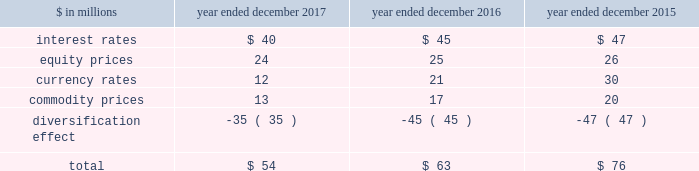The goldman sachs group , inc .
And subsidiaries management 2019s discussion and analysis the risk committee of the board and the risk governance committee ( through delegated authority from the firmwide risk committee ) approve market risk limits and sub-limits at firmwide , business and product levels , consistent with our risk appetite statement .
In addition , market risk management ( through delegated authority from the risk governance committee ) sets market risk limits and sub-limits at certain product and desk levels .
The purpose of the firmwide limits is to assist senior management in controlling our overall risk profile .
Sub-limits are set below the approved level of risk limits .
Sub-limits set the desired maximum amount of exposure that may be managed by any particular business on a day-to-day basis without additional levels of senior management approval , effectively leaving day-to-day decisions to individual desk managers and traders .
Accordingly , sub-limits are a management tool designed to ensure appropriate escalation rather than to establish maximum risk tolerance .
Sub-limits also distribute risk among various businesses in a manner that is consistent with their level of activity and client demand , taking into account the relative performance of each area .
Our market risk limits are monitored daily by market risk management , which is responsible for identifying and escalating , on a timely basis , instances where limits have been exceeded .
When a risk limit has been exceeded ( e.g. , due to positional changes or changes in market conditions , such as increased volatilities or changes in correlations ) , it is escalated to senior managers in market risk management and/or the appropriate risk committee .
Such instances are remediated by an inventory reduction and/or a temporary or permanent increase to the risk limit .
Model review and validation our var and stress testing models are regularly reviewed by market risk management and enhanced in order to incorporate changes in the composition of positions included in our market risk measures , as well as variations in market conditions .
Prior to implementing significant changes to our assumptions and/or models , model risk management performs model validations .
Significant changes to our var and stress testing models are reviewed with our chief risk officer and chief financial officer , and approved by the firmwide risk committee .
See 201cmodel risk management 201d for further information about the review and validation of these models .
Systems we have made a significant investment in technology to monitor market risk including : 2030 an independent calculation of var and stress measures ; 2030 risk measures calculated at individual position levels ; 2030 attribution of risk measures to individual risk factors of each position ; 2030 the ability to report many different views of the risk measures ( e.g. , by desk , business , product type or entity ) ; 2030 the ability to produce ad hoc analyses in a timely manner .
Metrics we analyze var at the firmwide level and a variety of more detailed levels , including by risk category , business , and region .
The tables below present average daily var and period-end var , as well as the high and low var for the period .
Diversification effect in the tables below represents the difference between total var and the sum of the vars for the four risk categories .
This effect arises because the four market risk categories are not perfectly correlated .
The table below presents average daily var by risk category. .
Our average daily var decreased to $ 54 million in 2017 from $ 63 million in 2016 , due to reductions across all risk categories , partially offset by a decrease in the diversification effect .
The overall decrease was primarily due to lower levels of volatility .
Our average daily var decreased to $ 63 million in 2016 from $ 76 million in 2015 , due to reductions across all risk categories , partially offset by a decrease in the diversification effect .
The overall decrease was primarily due to reduced exposures .
Goldman sachs 2017 form 10-k 91 .
What was the percentage change in average daily var in the currency rates risk category between 2016 and 2017? 
Computations: ((12 - 21) / 21)
Answer: -0.42857. 